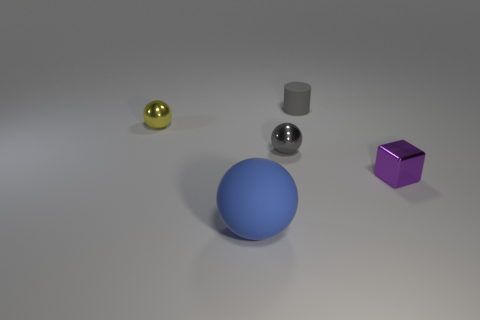Subtract all small yellow metal spheres. How many spheres are left? 2 Add 5 big cyan rubber balls. How many objects exist? 10 Subtract all cylinders. How many objects are left? 4 Add 1 large matte spheres. How many large matte spheres exist? 2 Subtract 0 brown cylinders. How many objects are left? 5 Subtract all small gray things. Subtract all yellow balls. How many objects are left? 2 Add 2 blue matte things. How many blue matte things are left? 3 